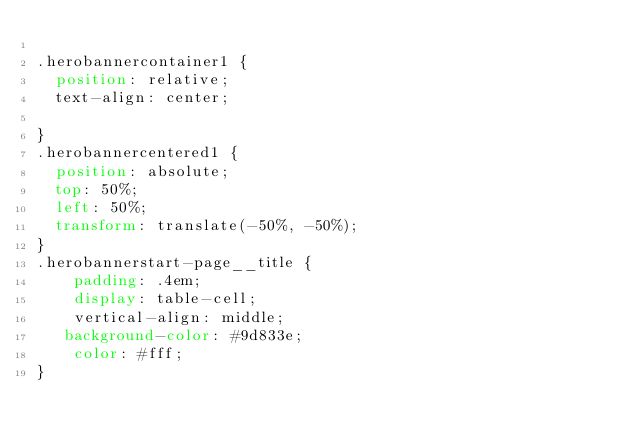<code> <loc_0><loc_0><loc_500><loc_500><_CSS_>
.herobannercontainer1 {
  position: relative;
  text-align: center;

}
.herobannercentered1 {
  position: absolute;
  top: 50%;
  left: 50%;
  transform: translate(-50%, -50%);
}
.herobannerstart-page__title {
    padding: .4em;
    display: table-cell;
    vertical-align: middle;
   background-color: #9d833e;
    color: #fff;
}

</code> 